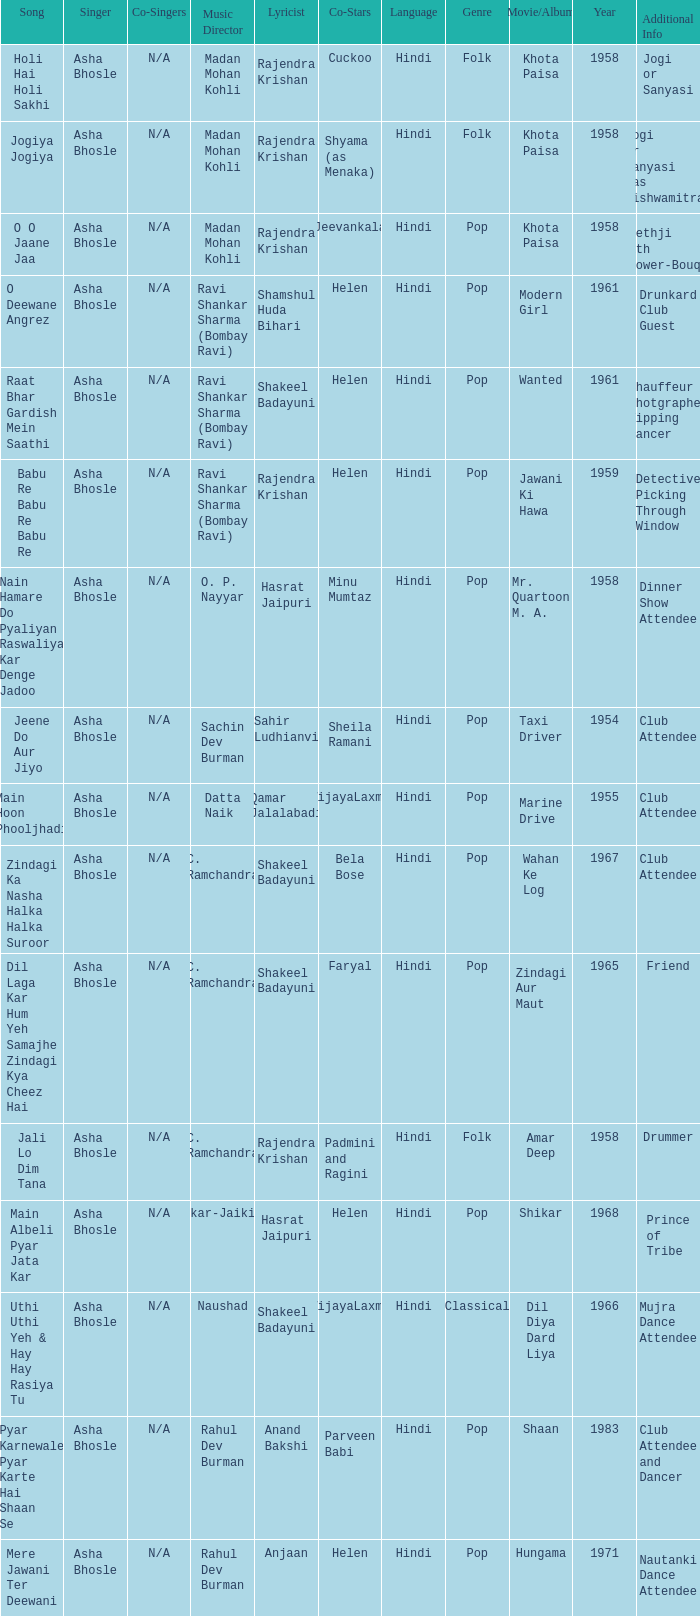What movie did Vijayalaxmi Co-star in and Shakeel Badayuni write the lyrics? Dil Diya Dard Liya. 